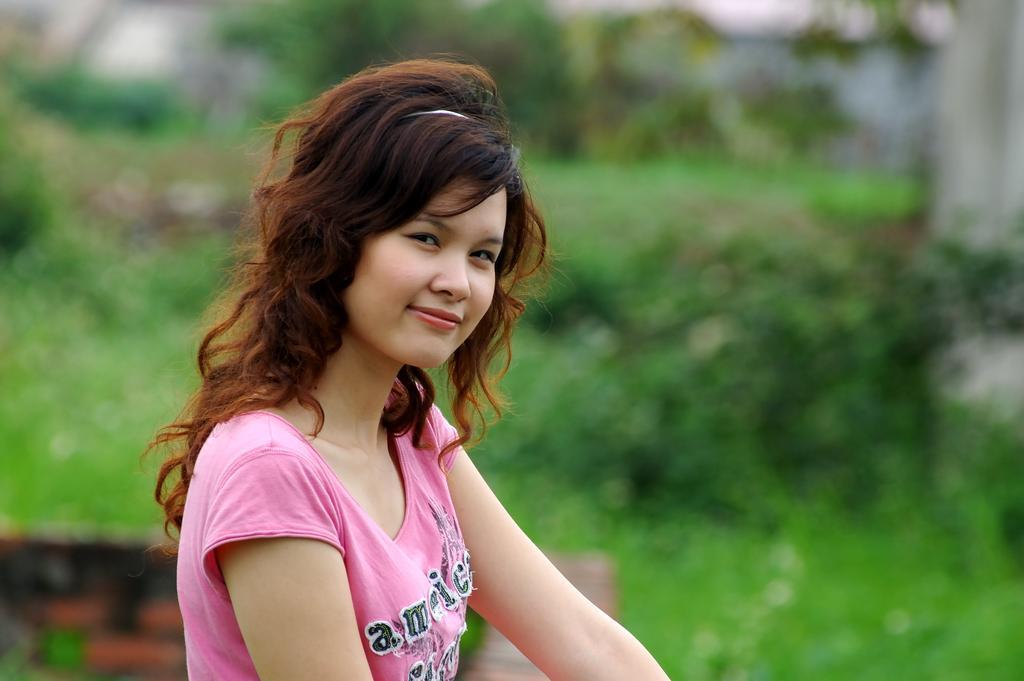In one or two sentences, can you explain what this image depicts? In this image I can see a woman is looking at this side. At the back side there are trees. 